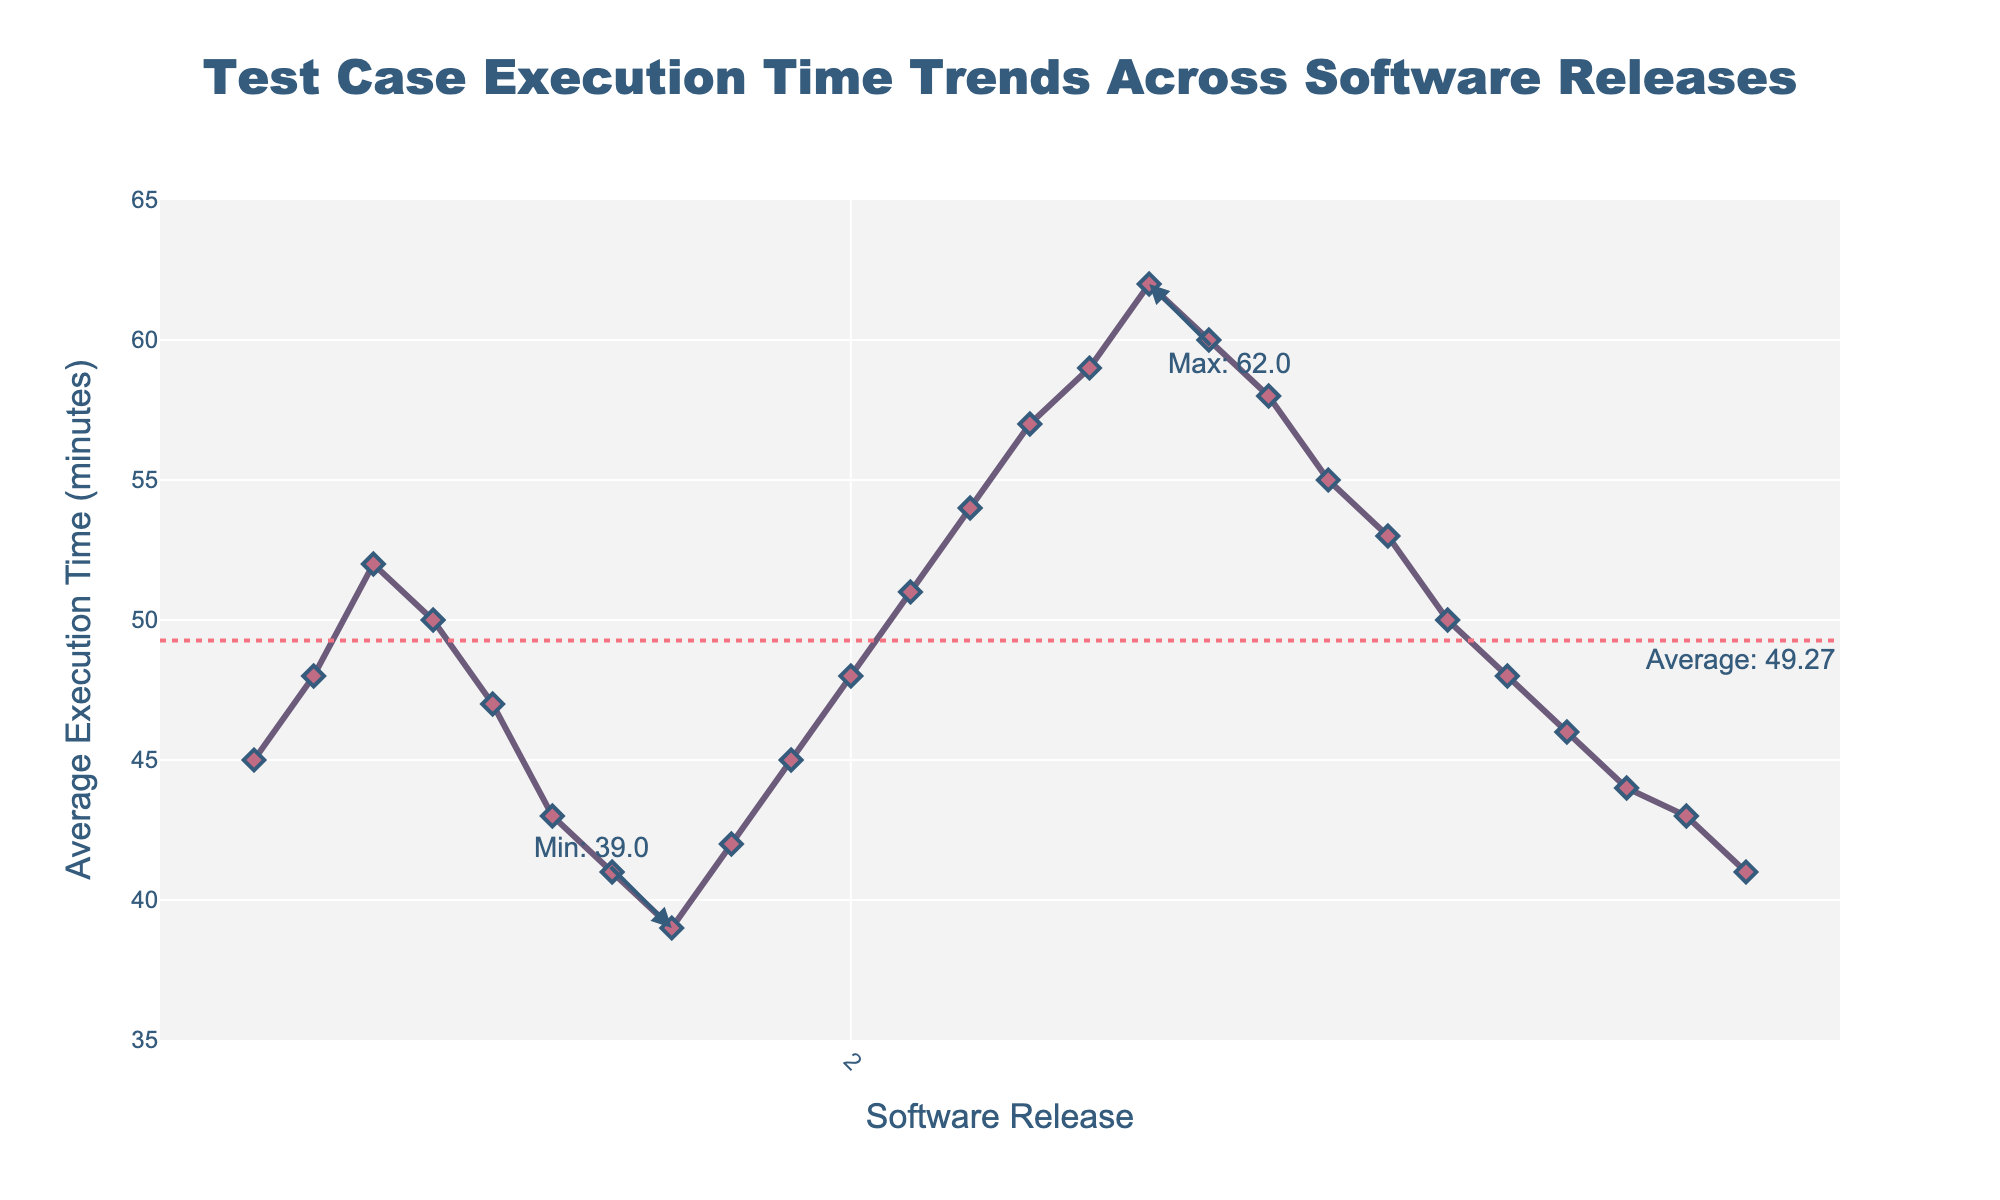what is the overall trend of the average execution time across the software releases? The line chart shows a fluctuating trend with peaks and valleys. The execution time initially increases, then decreases, then increases again to a higher peak, before gradually decreasing towards the end.
Answer: Fluctuating with a decreasing trend in the latter part Which software release has the maximum average execution time? The annotation on the figure shows the maximum average execution time with a marker and text. The highest point is at release 2.5 with an average execution time of 62 minutes.
Answer: Release 2.5 What is the average execution time across all the releases? The plot includes a horizontal dotted line representing the overall average execution time, with an annotation indicating the value. By looking at this line, we see the average execution time is approximately 50.08 minutes.
Answer: 50.08 minutes Between which two consecutive releases was there the greatest decrease in execution time? To identify the greatest decrease, we look for the steepest downward slope between two consecutive points. From release 2.5 to 2.6, the execution time drops from 62 to 60 minutes.
Answer: Between releases 2.5 and 2.6 During which releases is the execution time below the overall average? The overall average is noted by a horizontal dotted line. The releases where the execution time data points are below this line are 1.6, 1.7, 1.8, 1.9, 3.0, 3.1, 3.2, 3.3, 3.4, and 3.5.
Answer: Releases 1.6, 1.7, 1.8, 1.9, 3.0-3.5 How does the execution time of release 3.0 compare to release 1.0? By comparing the y-values of the data points on the line chart, we see that release 3.0 has an execution time of 50 minutes, while release 1.0 has an execution time of 45 minutes. Release 3.0's execution time is higher by 5 minutes than release 1.0.
Answer: 5 minutes higher What is the median release in terms of average execution time? To find the median, the releases need to be sorted by execution time, and the middle value identified. In this case, since there are 25 releases, the median (13th value in sorted order) is found from the data, which is release 2.3 with an execution time of 57 minutes.
Answer: Release 2.3 Which release shows a decrease in execution time compared to its previous release, after the maximum execution time release? Examining the chart after release 2.5 (maximum execution point), release 2.6 shows a decrease in execution time compared to 2.5, and further releases continue to show decreasing trends.
Answer: Release 2.6 Are there any releases where the execution time stayed the same or nearly the same compared to its previous release? Checking the y-values of consecutive points, releases 1.9 and 2.0 have the same average execution time of 45 minutes. Similarly, releases 3.5 and 1.6 both show a similar time near 41 minutes.
Answer: Releases 1.9, 2.0, 3.4, 3.5 What was the approximate execution time for the releases around the midpoint of the data range? The midpoint, around release 1.6 to 2.5 (13th value in 25 releases), shows the execution times rising from 41 to 62 minutes.
Answer: From 41 to 62 minutes 